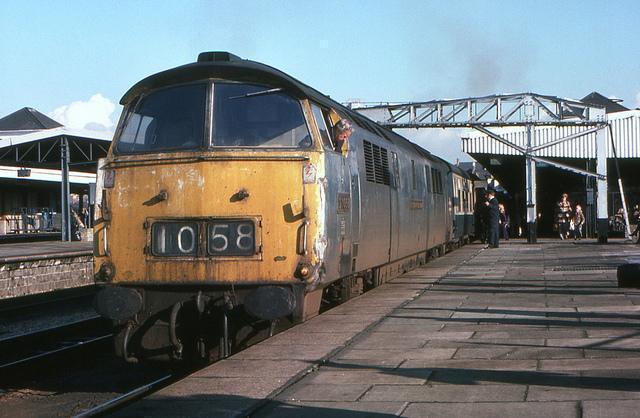What metro train number is this?
Answer the question by selecting the correct answer among the 4 following choices.
Options: 8501, 1058, 5810, 8051. 1058. 